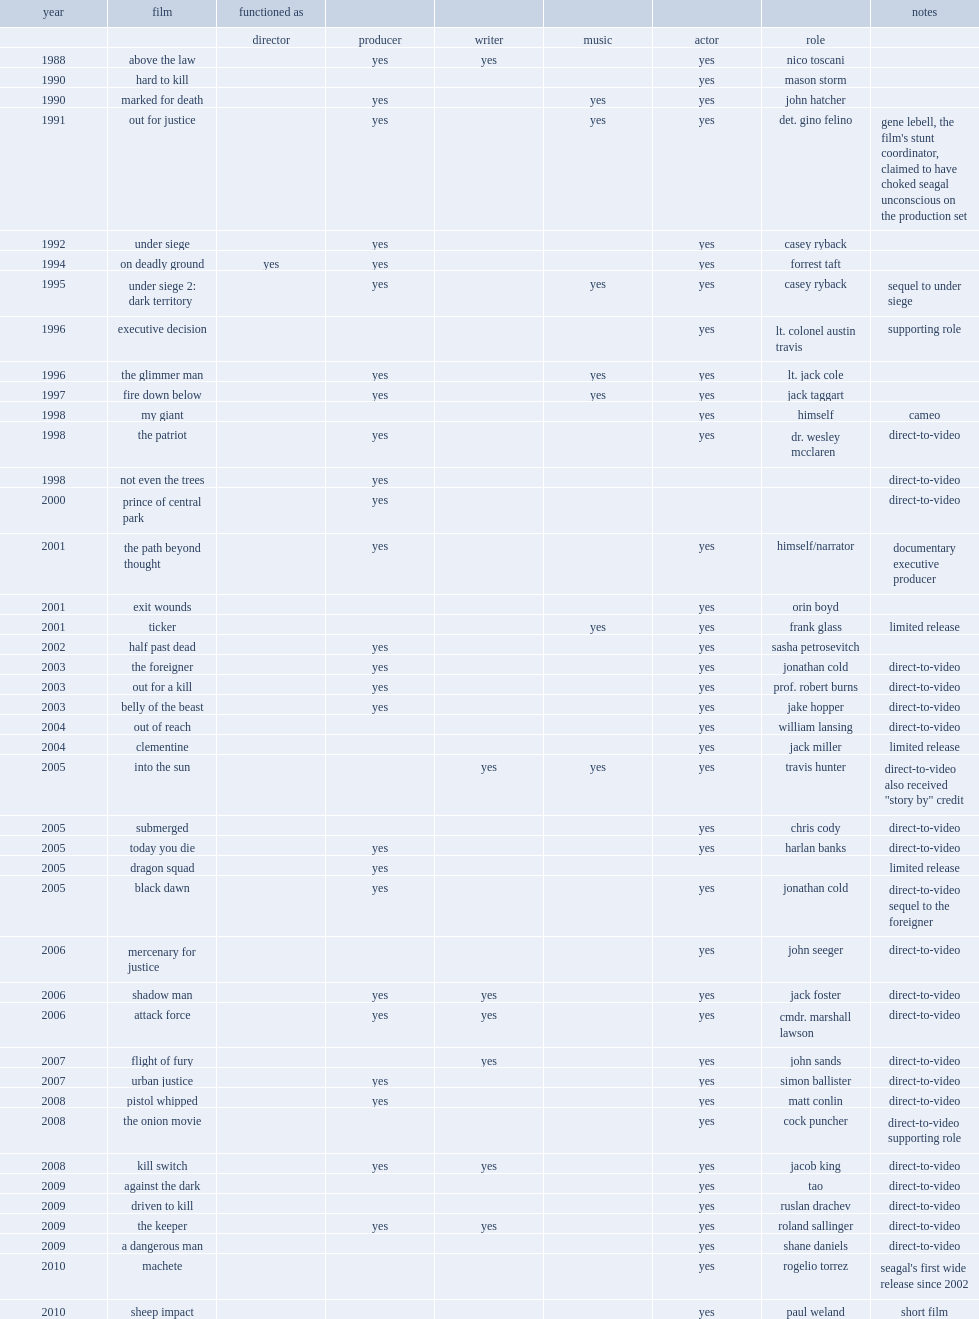In 1992, what the role did steven seagal play in under siege? Casey ryback. 